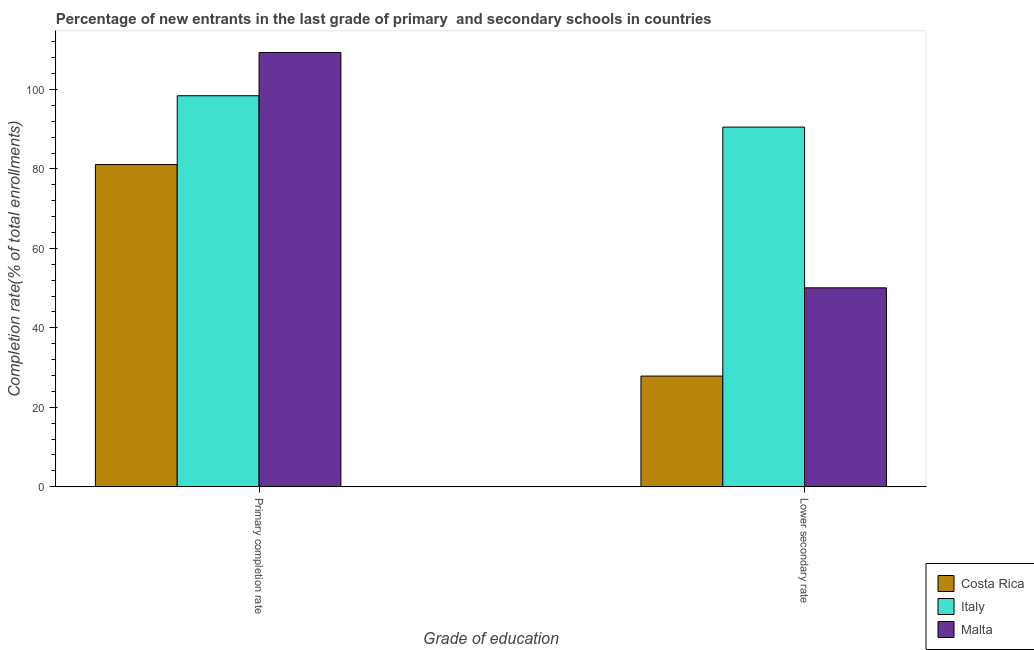How many different coloured bars are there?
Offer a terse response. 3. What is the label of the 1st group of bars from the left?
Keep it short and to the point. Primary completion rate. What is the completion rate in secondary schools in Italy?
Give a very brief answer. 90.52. Across all countries, what is the maximum completion rate in secondary schools?
Ensure brevity in your answer.  90.52. Across all countries, what is the minimum completion rate in secondary schools?
Provide a succinct answer. 27.85. In which country was the completion rate in secondary schools maximum?
Make the answer very short. Italy. What is the total completion rate in secondary schools in the graph?
Provide a short and direct response. 168.44. What is the difference between the completion rate in primary schools in Italy and that in Malta?
Give a very brief answer. -10.88. What is the difference between the completion rate in primary schools in Costa Rica and the completion rate in secondary schools in Malta?
Offer a terse response. 31.03. What is the average completion rate in primary schools per country?
Give a very brief answer. 96.27. What is the difference between the completion rate in secondary schools and completion rate in primary schools in Malta?
Keep it short and to the point. -59.23. In how many countries, is the completion rate in secondary schools greater than 104 %?
Make the answer very short. 0. What is the ratio of the completion rate in secondary schools in Costa Rica to that in Malta?
Provide a short and direct response. 0.56. Is the completion rate in secondary schools in Italy less than that in Costa Rica?
Make the answer very short. No. What does the 2nd bar from the left in Primary completion rate represents?
Your answer should be compact. Italy. What does the 1st bar from the right in Primary completion rate represents?
Offer a terse response. Malta. How many bars are there?
Ensure brevity in your answer.  6. What is the difference between two consecutive major ticks on the Y-axis?
Provide a succinct answer. 20. Are the values on the major ticks of Y-axis written in scientific E-notation?
Your response must be concise. No. Does the graph contain grids?
Provide a short and direct response. No. Where does the legend appear in the graph?
Give a very brief answer. Bottom right. What is the title of the graph?
Keep it short and to the point. Percentage of new entrants in the last grade of primary  and secondary schools in countries. Does "Ecuador" appear as one of the legend labels in the graph?
Provide a short and direct response. No. What is the label or title of the X-axis?
Give a very brief answer. Grade of education. What is the label or title of the Y-axis?
Your answer should be very brief. Completion rate(% of total enrollments). What is the Completion rate(% of total enrollments) of Costa Rica in Primary completion rate?
Your answer should be compact. 81.1. What is the Completion rate(% of total enrollments) in Italy in Primary completion rate?
Provide a short and direct response. 98.42. What is the Completion rate(% of total enrollments) in Malta in Primary completion rate?
Your response must be concise. 109.29. What is the Completion rate(% of total enrollments) in Costa Rica in Lower secondary rate?
Your answer should be compact. 27.85. What is the Completion rate(% of total enrollments) in Italy in Lower secondary rate?
Offer a very short reply. 90.52. What is the Completion rate(% of total enrollments) in Malta in Lower secondary rate?
Offer a very short reply. 50.06. Across all Grade of education, what is the maximum Completion rate(% of total enrollments) of Costa Rica?
Your answer should be very brief. 81.1. Across all Grade of education, what is the maximum Completion rate(% of total enrollments) in Italy?
Your answer should be compact. 98.42. Across all Grade of education, what is the maximum Completion rate(% of total enrollments) of Malta?
Keep it short and to the point. 109.29. Across all Grade of education, what is the minimum Completion rate(% of total enrollments) of Costa Rica?
Your response must be concise. 27.85. Across all Grade of education, what is the minimum Completion rate(% of total enrollments) of Italy?
Your answer should be very brief. 90.52. Across all Grade of education, what is the minimum Completion rate(% of total enrollments) of Malta?
Give a very brief answer. 50.06. What is the total Completion rate(% of total enrollments) in Costa Rica in the graph?
Your answer should be very brief. 108.95. What is the total Completion rate(% of total enrollments) in Italy in the graph?
Offer a terse response. 188.94. What is the total Completion rate(% of total enrollments) of Malta in the graph?
Ensure brevity in your answer.  159.36. What is the difference between the Completion rate(% of total enrollments) in Costa Rica in Primary completion rate and that in Lower secondary rate?
Ensure brevity in your answer.  53.24. What is the difference between the Completion rate(% of total enrollments) in Italy in Primary completion rate and that in Lower secondary rate?
Keep it short and to the point. 7.89. What is the difference between the Completion rate(% of total enrollments) in Malta in Primary completion rate and that in Lower secondary rate?
Keep it short and to the point. 59.23. What is the difference between the Completion rate(% of total enrollments) of Costa Rica in Primary completion rate and the Completion rate(% of total enrollments) of Italy in Lower secondary rate?
Provide a succinct answer. -9.43. What is the difference between the Completion rate(% of total enrollments) of Costa Rica in Primary completion rate and the Completion rate(% of total enrollments) of Malta in Lower secondary rate?
Offer a terse response. 31.03. What is the difference between the Completion rate(% of total enrollments) of Italy in Primary completion rate and the Completion rate(% of total enrollments) of Malta in Lower secondary rate?
Ensure brevity in your answer.  48.35. What is the average Completion rate(% of total enrollments) of Costa Rica per Grade of education?
Your answer should be compact. 54.47. What is the average Completion rate(% of total enrollments) in Italy per Grade of education?
Keep it short and to the point. 94.47. What is the average Completion rate(% of total enrollments) in Malta per Grade of education?
Your response must be concise. 79.68. What is the difference between the Completion rate(% of total enrollments) of Costa Rica and Completion rate(% of total enrollments) of Italy in Primary completion rate?
Offer a very short reply. -17.32. What is the difference between the Completion rate(% of total enrollments) of Costa Rica and Completion rate(% of total enrollments) of Malta in Primary completion rate?
Offer a terse response. -28.2. What is the difference between the Completion rate(% of total enrollments) of Italy and Completion rate(% of total enrollments) of Malta in Primary completion rate?
Provide a succinct answer. -10.88. What is the difference between the Completion rate(% of total enrollments) of Costa Rica and Completion rate(% of total enrollments) of Italy in Lower secondary rate?
Offer a terse response. -62.67. What is the difference between the Completion rate(% of total enrollments) in Costa Rica and Completion rate(% of total enrollments) in Malta in Lower secondary rate?
Provide a short and direct response. -22.21. What is the difference between the Completion rate(% of total enrollments) of Italy and Completion rate(% of total enrollments) of Malta in Lower secondary rate?
Keep it short and to the point. 40.46. What is the ratio of the Completion rate(% of total enrollments) in Costa Rica in Primary completion rate to that in Lower secondary rate?
Offer a terse response. 2.91. What is the ratio of the Completion rate(% of total enrollments) in Italy in Primary completion rate to that in Lower secondary rate?
Keep it short and to the point. 1.09. What is the ratio of the Completion rate(% of total enrollments) in Malta in Primary completion rate to that in Lower secondary rate?
Keep it short and to the point. 2.18. What is the difference between the highest and the second highest Completion rate(% of total enrollments) in Costa Rica?
Offer a very short reply. 53.24. What is the difference between the highest and the second highest Completion rate(% of total enrollments) in Italy?
Offer a very short reply. 7.89. What is the difference between the highest and the second highest Completion rate(% of total enrollments) of Malta?
Make the answer very short. 59.23. What is the difference between the highest and the lowest Completion rate(% of total enrollments) in Costa Rica?
Offer a terse response. 53.24. What is the difference between the highest and the lowest Completion rate(% of total enrollments) of Italy?
Provide a short and direct response. 7.89. What is the difference between the highest and the lowest Completion rate(% of total enrollments) of Malta?
Provide a short and direct response. 59.23. 